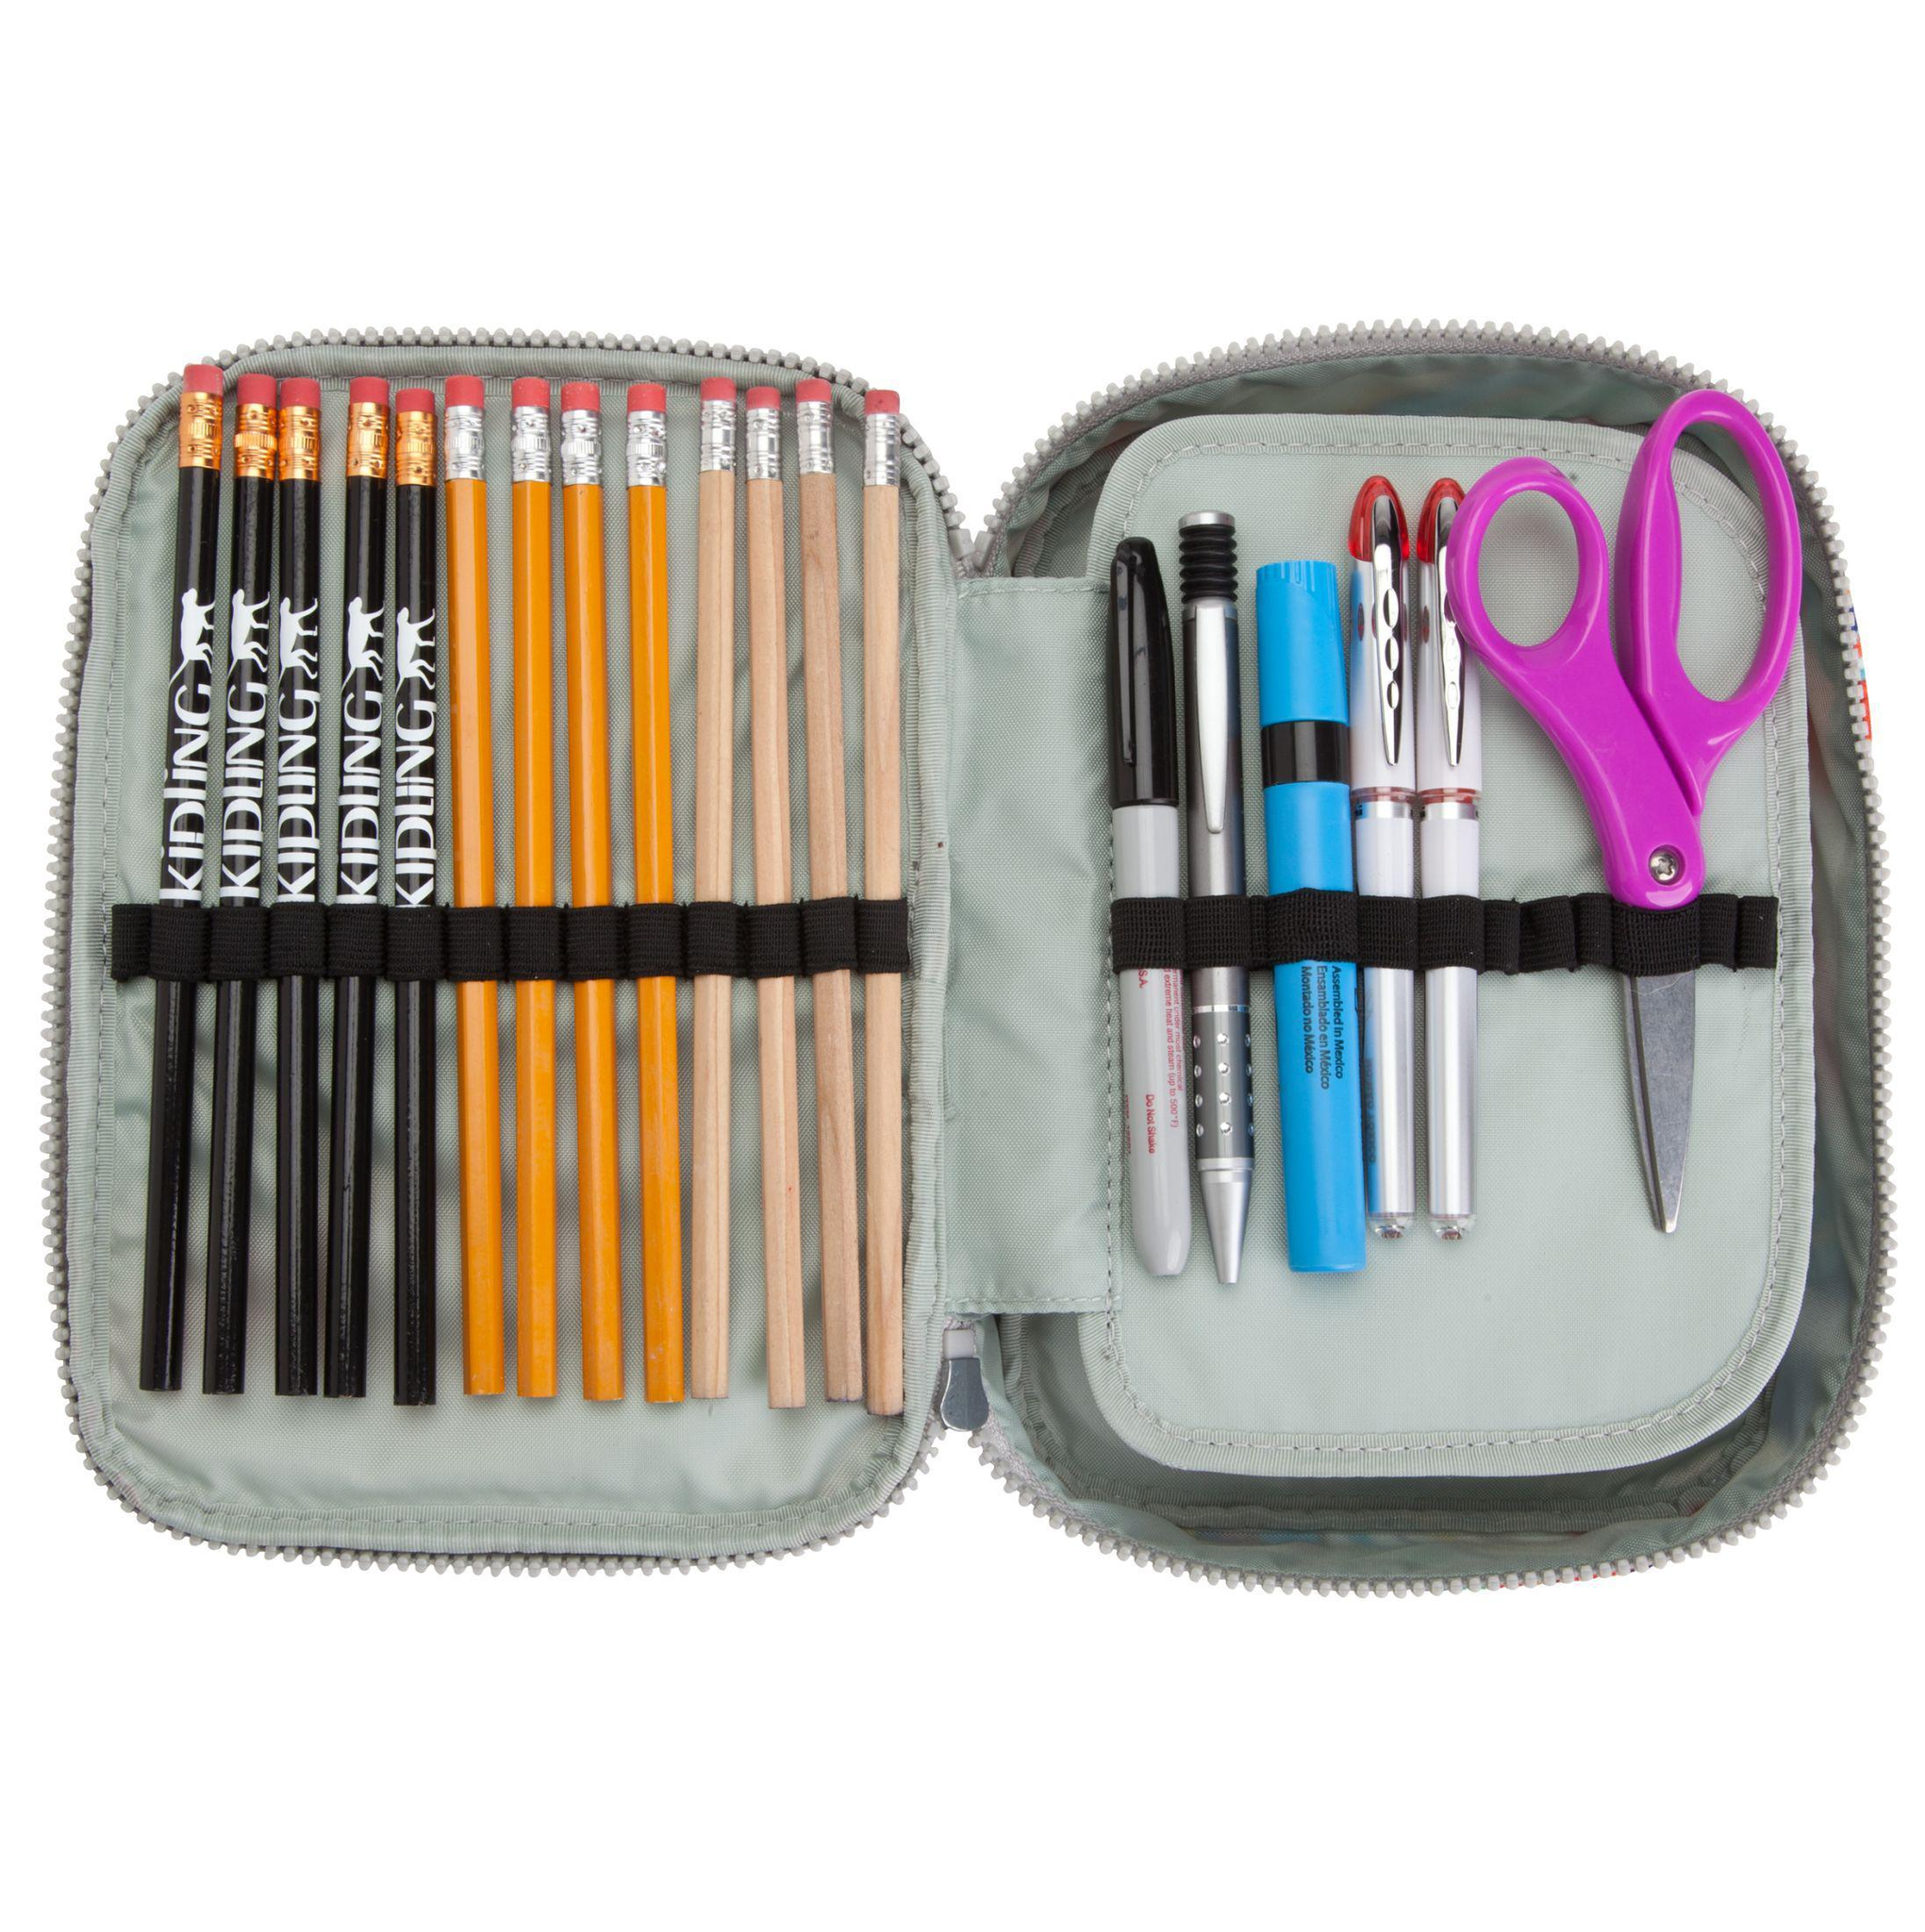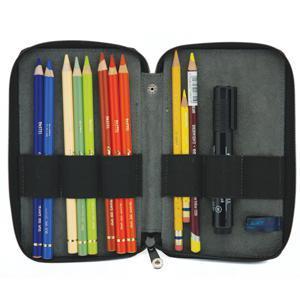The first image is the image on the left, the second image is the image on the right. For the images shown, is this caption "One container has a pair of scissors." true? Answer yes or no. Yes. The first image is the image on the left, the second image is the image on the right. Considering the images on both sides, is "There is at least one pair of scissors inside of the binder in one of the images." valid? Answer yes or no. Yes. 